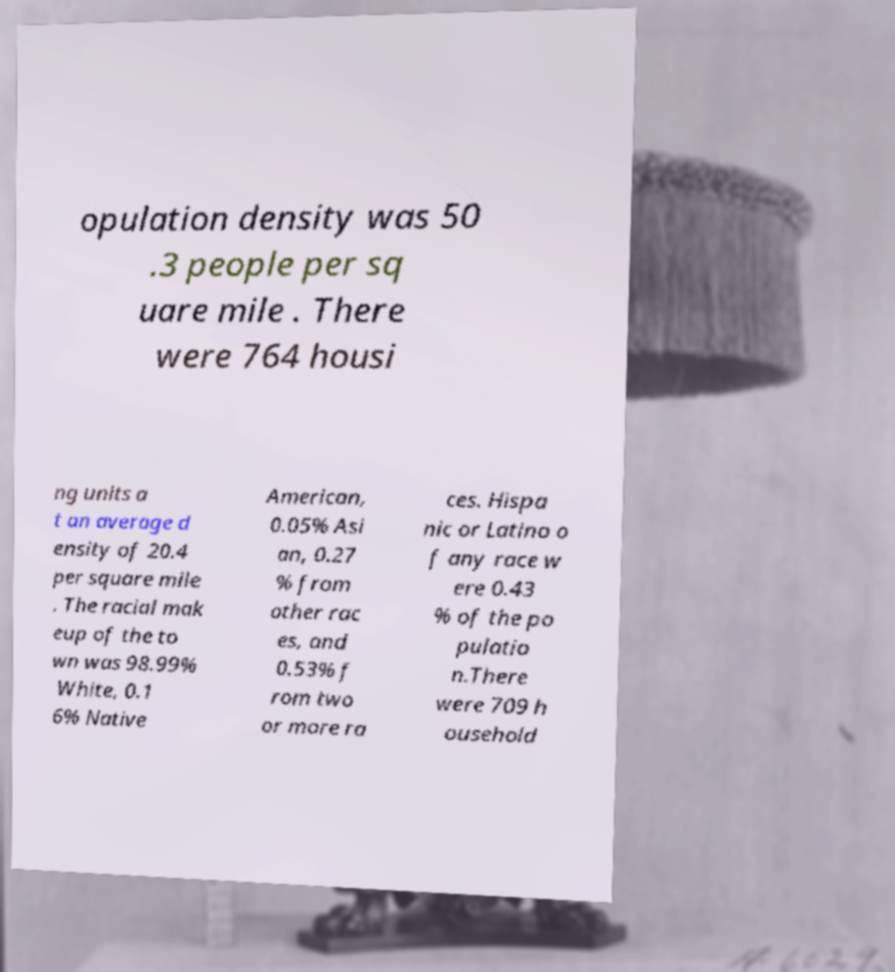For documentation purposes, I need the text within this image transcribed. Could you provide that? opulation density was 50 .3 people per sq uare mile . There were 764 housi ng units a t an average d ensity of 20.4 per square mile . The racial mak eup of the to wn was 98.99% White, 0.1 6% Native American, 0.05% Asi an, 0.27 % from other rac es, and 0.53% f rom two or more ra ces. Hispa nic or Latino o f any race w ere 0.43 % of the po pulatio n.There were 709 h ousehold 